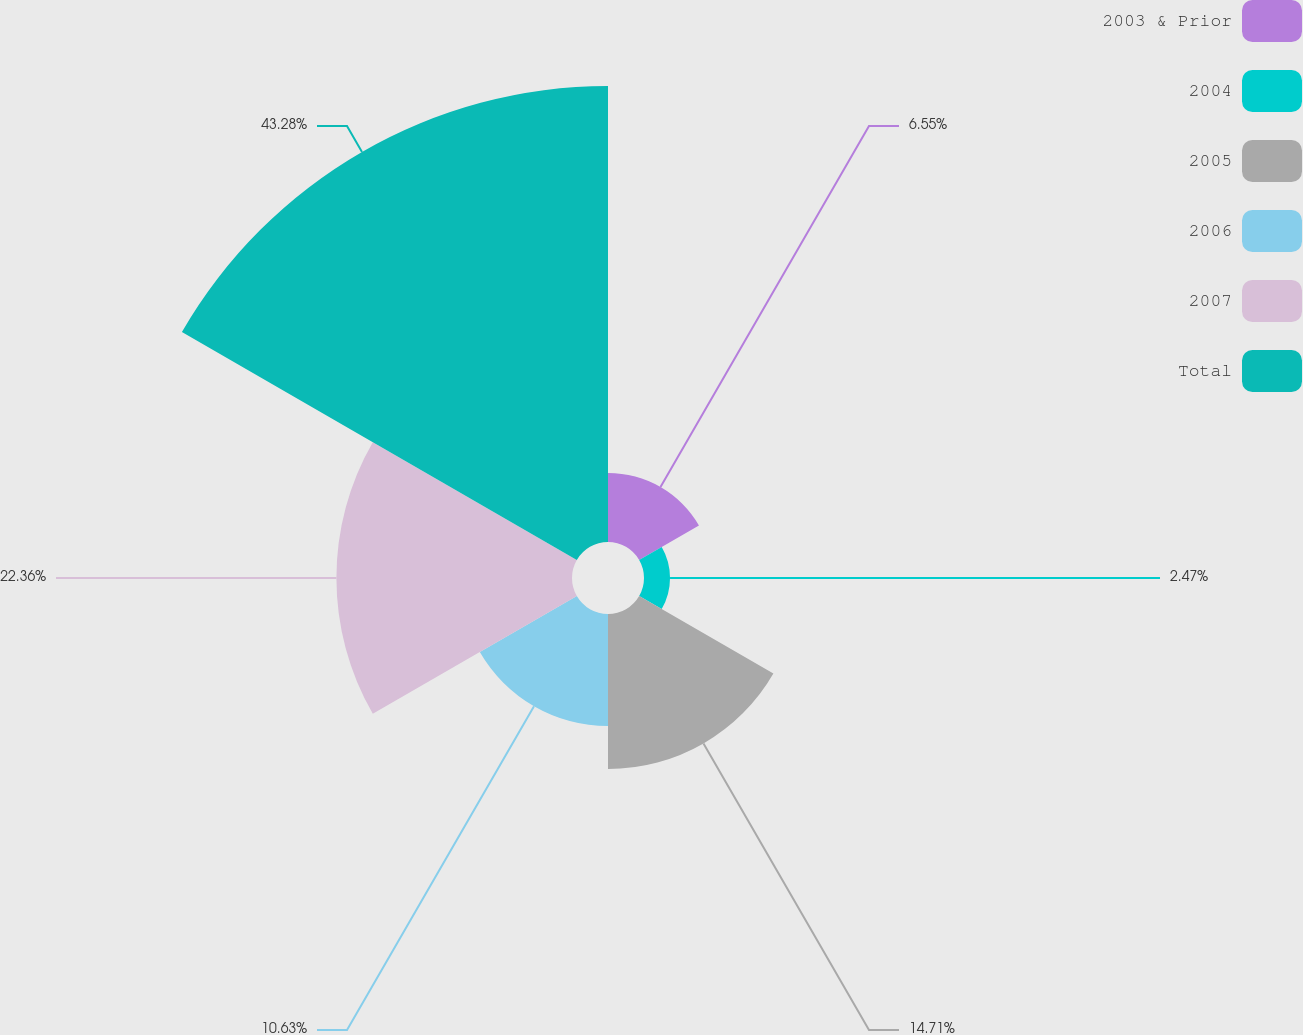Convert chart to OTSL. <chart><loc_0><loc_0><loc_500><loc_500><pie_chart><fcel>2003 & Prior<fcel>2004<fcel>2005<fcel>2006<fcel>2007<fcel>Total<nl><fcel>6.55%<fcel>2.47%<fcel>14.71%<fcel>10.63%<fcel>22.36%<fcel>43.28%<nl></chart> 